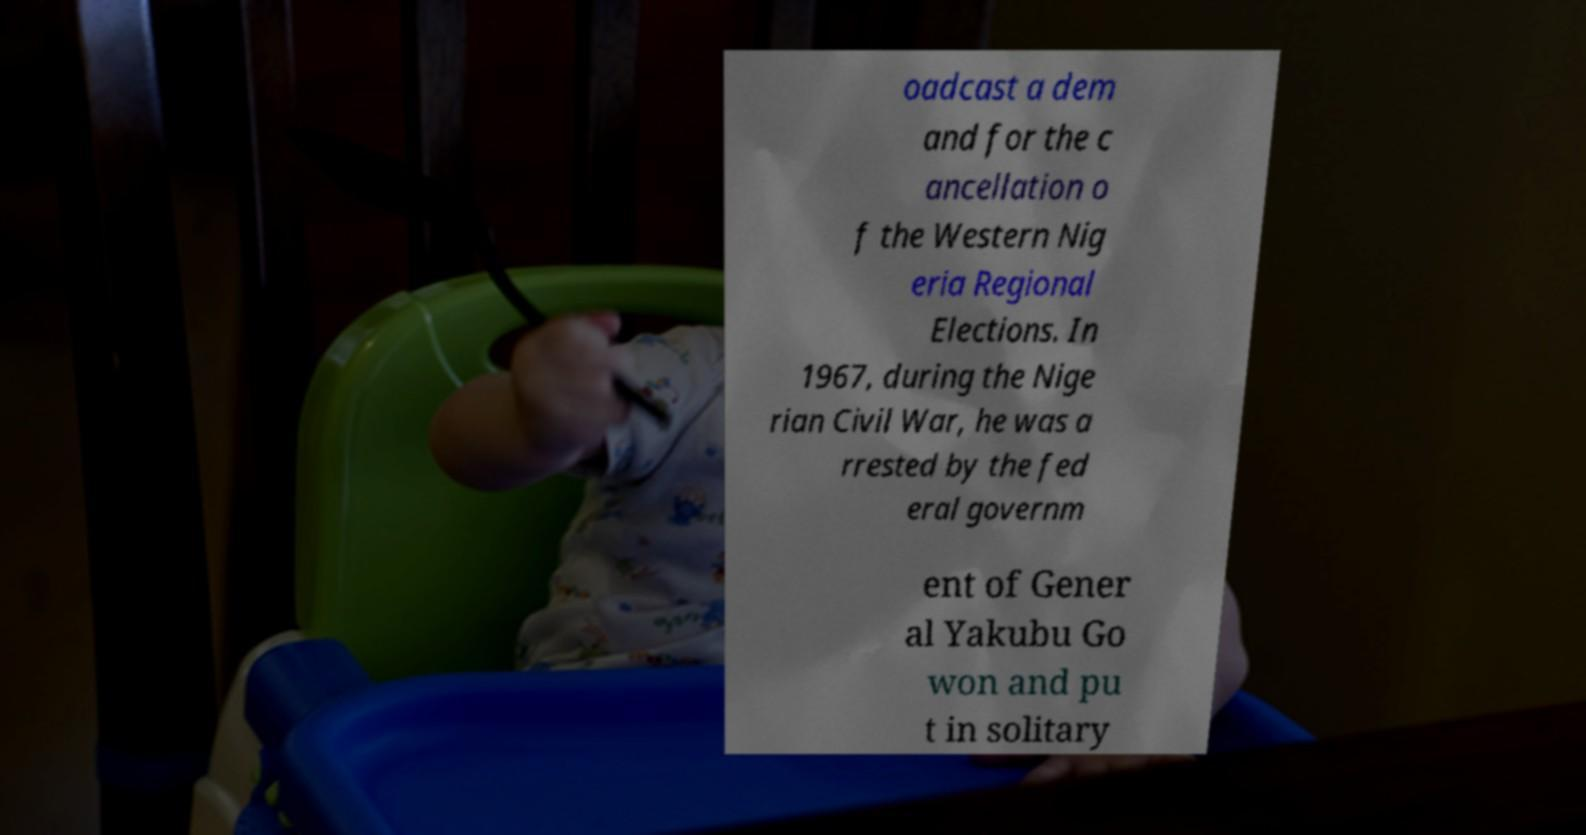Please read and relay the text visible in this image. What does it say? oadcast a dem and for the c ancellation o f the Western Nig eria Regional Elections. In 1967, during the Nige rian Civil War, he was a rrested by the fed eral governm ent of Gener al Yakubu Go won and pu t in solitary 